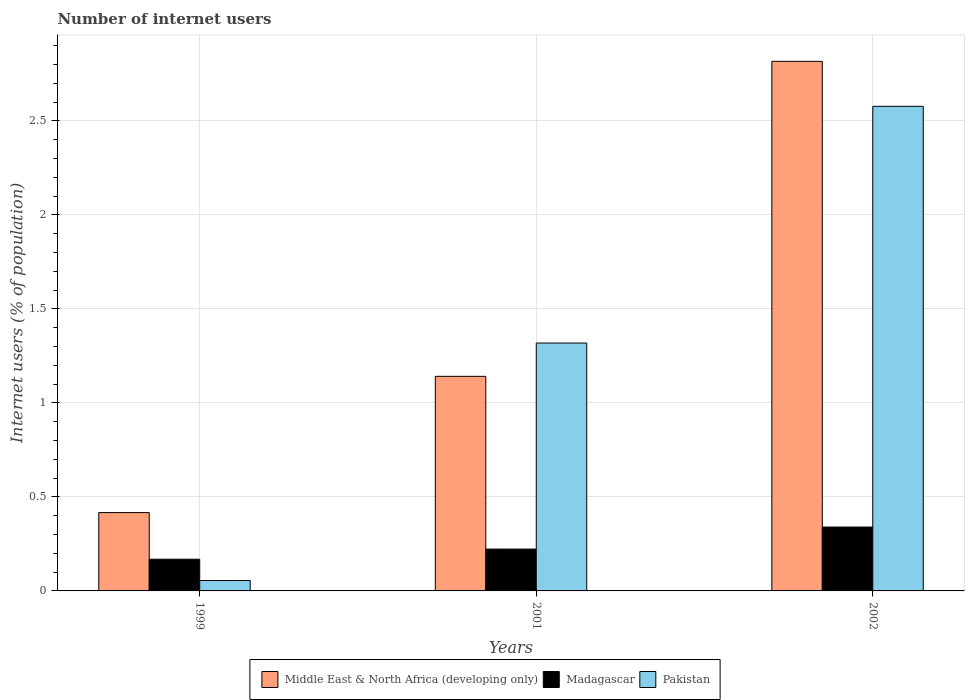How many groups of bars are there?
Offer a terse response. 3. Are the number of bars per tick equal to the number of legend labels?
Give a very brief answer. Yes. Are the number of bars on each tick of the X-axis equal?
Provide a succinct answer. Yes. How many bars are there on the 1st tick from the right?
Keep it short and to the point. 3. What is the label of the 2nd group of bars from the left?
Provide a succinct answer. 2001. What is the number of internet users in Pakistan in 2002?
Keep it short and to the point. 2.58. Across all years, what is the maximum number of internet users in Madagascar?
Give a very brief answer. 0.34. Across all years, what is the minimum number of internet users in Madagascar?
Provide a succinct answer. 0.17. In which year was the number of internet users in Middle East & North Africa (developing only) maximum?
Your answer should be very brief. 2002. What is the total number of internet users in Pakistan in the graph?
Your response must be concise. 3.95. What is the difference between the number of internet users in Pakistan in 1999 and that in 2001?
Your answer should be very brief. -1.26. What is the difference between the number of internet users in Middle East & North Africa (developing only) in 2001 and the number of internet users in Pakistan in 2002?
Offer a terse response. -1.44. What is the average number of internet users in Middle East & North Africa (developing only) per year?
Provide a short and direct response. 1.46. In the year 2001, what is the difference between the number of internet users in Middle East & North Africa (developing only) and number of internet users in Madagascar?
Your answer should be very brief. 0.92. In how many years, is the number of internet users in Middle East & North Africa (developing only) greater than 0.5 %?
Make the answer very short. 2. What is the ratio of the number of internet users in Middle East & North Africa (developing only) in 2001 to that in 2002?
Offer a very short reply. 0.41. Is the number of internet users in Madagascar in 2001 less than that in 2002?
Provide a succinct answer. Yes. What is the difference between the highest and the second highest number of internet users in Pakistan?
Keep it short and to the point. 1.26. What is the difference between the highest and the lowest number of internet users in Middle East & North Africa (developing only)?
Provide a succinct answer. 2.4. What does the 2nd bar from the left in 2002 represents?
Provide a succinct answer. Madagascar. What does the 2nd bar from the right in 1999 represents?
Offer a very short reply. Madagascar. How many bars are there?
Make the answer very short. 9. How many years are there in the graph?
Your response must be concise. 3. Where does the legend appear in the graph?
Offer a terse response. Bottom center. How many legend labels are there?
Your answer should be compact. 3. What is the title of the graph?
Your answer should be compact. Number of internet users. Does "Uganda" appear as one of the legend labels in the graph?
Your response must be concise. No. What is the label or title of the Y-axis?
Keep it short and to the point. Internet users (% of population). What is the Internet users (% of population) of Middle East & North Africa (developing only) in 1999?
Make the answer very short. 0.42. What is the Internet users (% of population) in Madagascar in 1999?
Your response must be concise. 0.17. What is the Internet users (% of population) of Pakistan in 1999?
Keep it short and to the point. 0.06. What is the Internet users (% of population) in Middle East & North Africa (developing only) in 2001?
Provide a succinct answer. 1.14. What is the Internet users (% of population) in Madagascar in 2001?
Offer a very short reply. 0.22. What is the Internet users (% of population) in Pakistan in 2001?
Offer a terse response. 1.32. What is the Internet users (% of population) of Middle East & North Africa (developing only) in 2002?
Give a very brief answer. 2.82. What is the Internet users (% of population) in Madagascar in 2002?
Your answer should be compact. 0.34. What is the Internet users (% of population) of Pakistan in 2002?
Ensure brevity in your answer.  2.58. Across all years, what is the maximum Internet users (% of population) of Middle East & North Africa (developing only)?
Your answer should be very brief. 2.82. Across all years, what is the maximum Internet users (% of population) of Madagascar?
Make the answer very short. 0.34. Across all years, what is the maximum Internet users (% of population) in Pakistan?
Make the answer very short. 2.58. Across all years, what is the minimum Internet users (% of population) of Middle East & North Africa (developing only)?
Ensure brevity in your answer.  0.42. Across all years, what is the minimum Internet users (% of population) in Madagascar?
Your response must be concise. 0.17. Across all years, what is the minimum Internet users (% of population) of Pakistan?
Offer a terse response. 0.06. What is the total Internet users (% of population) in Middle East & North Africa (developing only) in the graph?
Make the answer very short. 4.37. What is the total Internet users (% of population) in Madagascar in the graph?
Keep it short and to the point. 0.73. What is the total Internet users (% of population) in Pakistan in the graph?
Give a very brief answer. 3.95. What is the difference between the Internet users (% of population) in Middle East & North Africa (developing only) in 1999 and that in 2001?
Ensure brevity in your answer.  -0.72. What is the difference between the Internet users (% of population) of Madagascar in 1999 and that in 2001?
Keep it short and to the point. -0.05. What is the difference between the Internet users (% of population) in Pakistan in 1999 and that in 2001?
Make the answer very short. -1.26. What is the difference between the Internet users (% of population) in Middle East & North Africa (developing only) in 1999 and that in 2002?
Make the answer very short. -2.4. What is the difference between the Internet users (% of population) in Madagascar in 1999 and that in 2002?
Provide a short and direct response. -0.17. What is the difference between the Internet users (% of population) of Pakistan in 1999 and that in 2002?
Your answer should be compact. -2.52. What is the difference between the Internet users (% of population) of Middle East & North Africa (developing only) in 2001 and that in 2002?
Provide a succinct answer. -1.68. What is the difference between the Internet users (% of population) of Madagascar in 2001 and that in 2002?
Your response must be concise. -0.12. What is the difference between the Internet users (% of population) in Pakistan in 2001 and that in 2002?
Ensure brevity in your answer.  -1.26. What is the difference between the Internet users (% of population) of Middle East & North Africa (developing only) in 1999 and the Internet users (% of population) of Madagascar in 2001?
Your answer should be compact. 0.19. What is the difference between the Internet users (% of population) of Middle East & North Africa (developing only) in 1999 and the Internet users (% of population) of Pakistan in 2001?
Ensure brevity in your answer.  -0.9. What is the difference between the Internet users (% of population) of Madagascar in 1999 and the Internet users (% of population) of Pakistan in 2001?
Provide a short and direct response. -1.15. What is the difference between the Internet users (% of population) of Middle East & North Africa (developing only) in 1999 and the Internet users (% of population) of Madagascar in 2002?
Make the answer very short. 0.08. What is the difference between the Internet users (% of population) of Middle East & North Africa (developing only) in 1999 and the Internet users (% of population) of Pakistan in 2002?
Give a very brief answer. -2.16. What is the difference between the Internet users (% of population) in Madagascar in 1999 and the Internet users (% of population) in Pakistan in 2002?
Keep it short and to the point. -2.41. What is the difference between the Internet users (% of population) in Middle East & North Africa (developing only) in 2001 and the Internet users (% of population) in Madagascar in 2002?
Make the answer very short. 0.8. What is the difference between the Internet users (% of population) in Middle East & North Africa (developing only) in 2001 and the Internet users (% of population) in Pakistan in 2002?
Make the answer very short. -1.44. What is the difference between the Internet users (% of population) of Madagascar in 2001 and the Internet users (% of population) of Pakistan in 2002?
Provide a succinct answer. -2.35. What is the average Internet users (% of population) of Middle East & North Africa (developing only) per year?
Your response must be concise. 1.46. What is the average Internet users (% of population) in Madagascar per year?
Ensure brevity in your answer.  0.24. What is the average Internet users (% of population) of Pakistan per year?
Your answer should be very brief. 1.32. In the year 1999, what is the difference between the Internet users (% of population) in Middle East & North Africa (developing only) and Internet users (% of population) in Madagascar?
Your answer should be very brief. 0.25. In the year 1999, what is the difference between the Internet users (% of population) in Middle East & North Africa (developing only) and Internet users (% of population) in Pakistan?
Provide a short and direct response. 0.36. In the year 1999, what is the difference between the Internet users (% of population) in Madagascar and Internet users (% of population) in Pakistan?
Your response must be concise. 0.11. In the year 2001, what is the difference between the Internet users (% of population) in Middle East & North Africa (developing only) and Internet users (% of population) in Madagascar?
Make the answer very short. 0.92. In the year 2001, what is the difference between the Internet users (% of population) in Middle East & North Africa (developing only) and Internet users (% of population) in Pakistan?
Ensure brevity in your answer.  -0.18. In the year 2001, what is the difference between the Internet users (% of population) in Madagascar and Internet users (% of population) in Pakistan?
Provide a short and direct response. -1.1. In the year 2002, what is the difference between the Internet users (% of population) of Middle East & North Africa (developing only) and Internet users (% of population) of Madagascar?
Keep it short and to the point. 2.48. In the year 2002, what is the difference between the Internet users (% of population) of Middle East & North Africa (developing only) and Internet users (% of population) of Pakistan?
Offer a very short reply. 0.24. In the year 2002, what is the difference between the Internet users (% of population) in Madagascar and Internet users (% of population) in Pakistan?
Make the answer very short. -2.24. What is the ratio of the Internet users (% of population) of Middle East & North Africa (developing only) in 1999 to that in 2001?
Offer a terse response. 0.36. What is the ratio of the Internet users (% of population) of Madagascar in 1999 to that in 2001?
Your answer should be very brief. 0.76. What is the ratio of the Internet users (% of population) of Pakistan in 1999 to that in 2001?
Your answer should be very brief. 0.04. What is the ratio of the Internet users (% of population) of Middle East & North Africa (developing only) in 1999 to that in 2002?
Your response must be concise. 0.15. What is the ratio of the Internet users (% of population) in Madagascar in 1999 to that in 2002?
Make the answer very short. 0.5. What is the ratio of the Internet users (% of population) in Pakistan in 1999 to that in 2002?
Keep it short and to the point. 0.02. What is the ratio of the Internet users (% of population) in Middle East & North Africa (developing only) in 2001 to that in 2002?
Provide a succinct answer. 0.41. What is the ratio of the Internet users (% of population) of Madagascar in 2001 to that in 2002?
Ensure brevity in your answer.  0.66. What is the ratio of the Internet users (% of population) of Pakistan in 2001 to that in 2002?
Offer a very short reply. 0.51. What is the difference between the highest and the second highest Internet users (% of population) of Middle East & North Africa (developing only)?
Your response must be concise. 1.68. What is the difference between the highest and the second highest Internet users (% of population) of Madagascar?
Make the answer very short. 0.12. What is the difference between the highest and the second highest Internet users (% of population) in Pakistan?
Your answer should be very brief. 1.26. What is the difference between the highest and the lowest Internet users (% of population) of Middle East & North Africa (developing only)?
Your answer should be very brief. 2.4. What is the difference between the highest and the lowest Internet users (% of population) of Madagascar?
Ensure brevity in your answer.  0.17. What is the difference between the highest and the lowest Internet users (% of population) in Pakistan?
Your response must be concise. 2.52. 